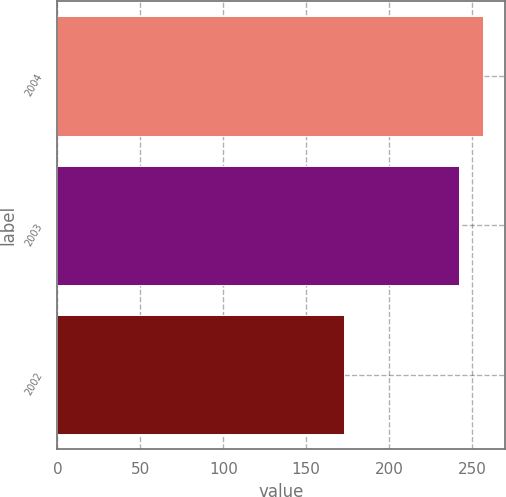<chart> <loc_0><loc_0><loc_500><loc_500><bar_chart><fcel>2004<fcel>2003<fcel>2002<nl><fcel>256.8<fcel>242.3<fcel>172.6<nl></chart> 